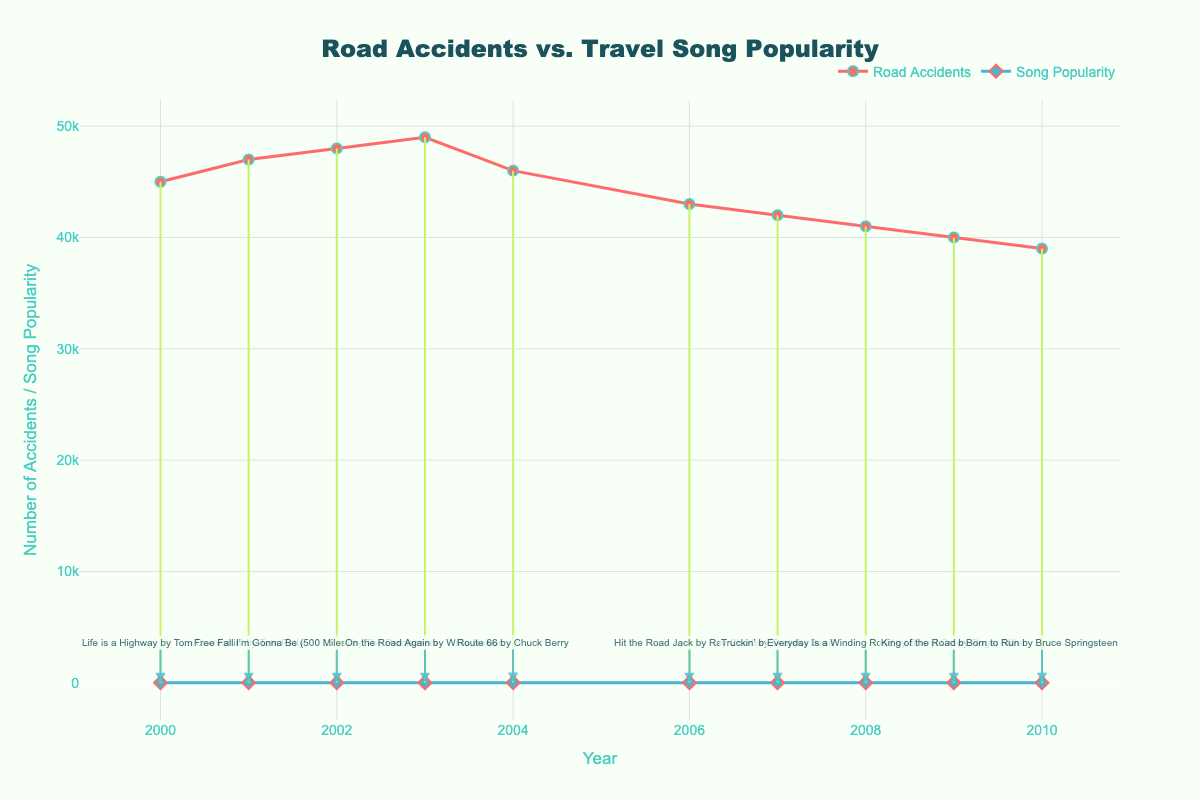What is the title of the plot? The title is written at the top center of the plot and reads "Road Accidents vs. Travel Song Popularity".
Answer: Road Accidents vs. Travel Song Popularity How many years of data are presented in the plot? By looking at the x-axis, we can count the data points for each year displayed from 2000 to 2010.
Answer: 10 Which year had the lowest number of road accidents? The lowest point on the line representing road accidents occurs at 2010, showing the least value.
Answer: 2010 In which year did the travel-themed song "Life is a Highway" peak, according to the plot? The song titles are annotated near the diamond markers, and "Life is a Highway" is closest to the year 2000.
Answer: 2000 Which year's travel-themed song had the highest popularity on the Billboard chart? The highest popularity is shown by the lowest number on the y-axis for song popularity, which is 11 in the year 2010 for "Born to Run".
Answer: 2010 What was the difference in road accidents between 2003 and 2010? From the plot, 2003 had 49000 accidents and 2010 had 39000 accidents. The difference is 49000 - 39000 = 10000.
Answer: 10000 Which year shows the largest difference between number of road accidents and song popularity? By examining the vertical lines connecting accidents and popularity, the longest line is between 49000 accidents and 21 popularity in 2003, resulting in a difference of 49000 - 21 = 48979.
Answer: 2003 Did the road accidents trend increase or decrease over the years shown in the plot? The line representing road accidents generally slopes downwards from 2000 to 2010, indicating a decrease.
Answer: Decrease Is there any year where the song's popularity and the number of road accidents are very close? The closest points for both markers can be observed in 2001 and 2008 where both lines are closer together. Specifically in 2008, 41000 accidents and 17 popularity are close.
Answer: 2008 What's the average song popularity for the given years? To calculate the average, sum up all the popularity values (12 + 19 + 15 + 21 + 24 + 14 + 13 + 17 + 16 + 11 = 162) and divide by the number of years (10). The average popularity is 162/10 = 16.2.
Answer: 16.2 